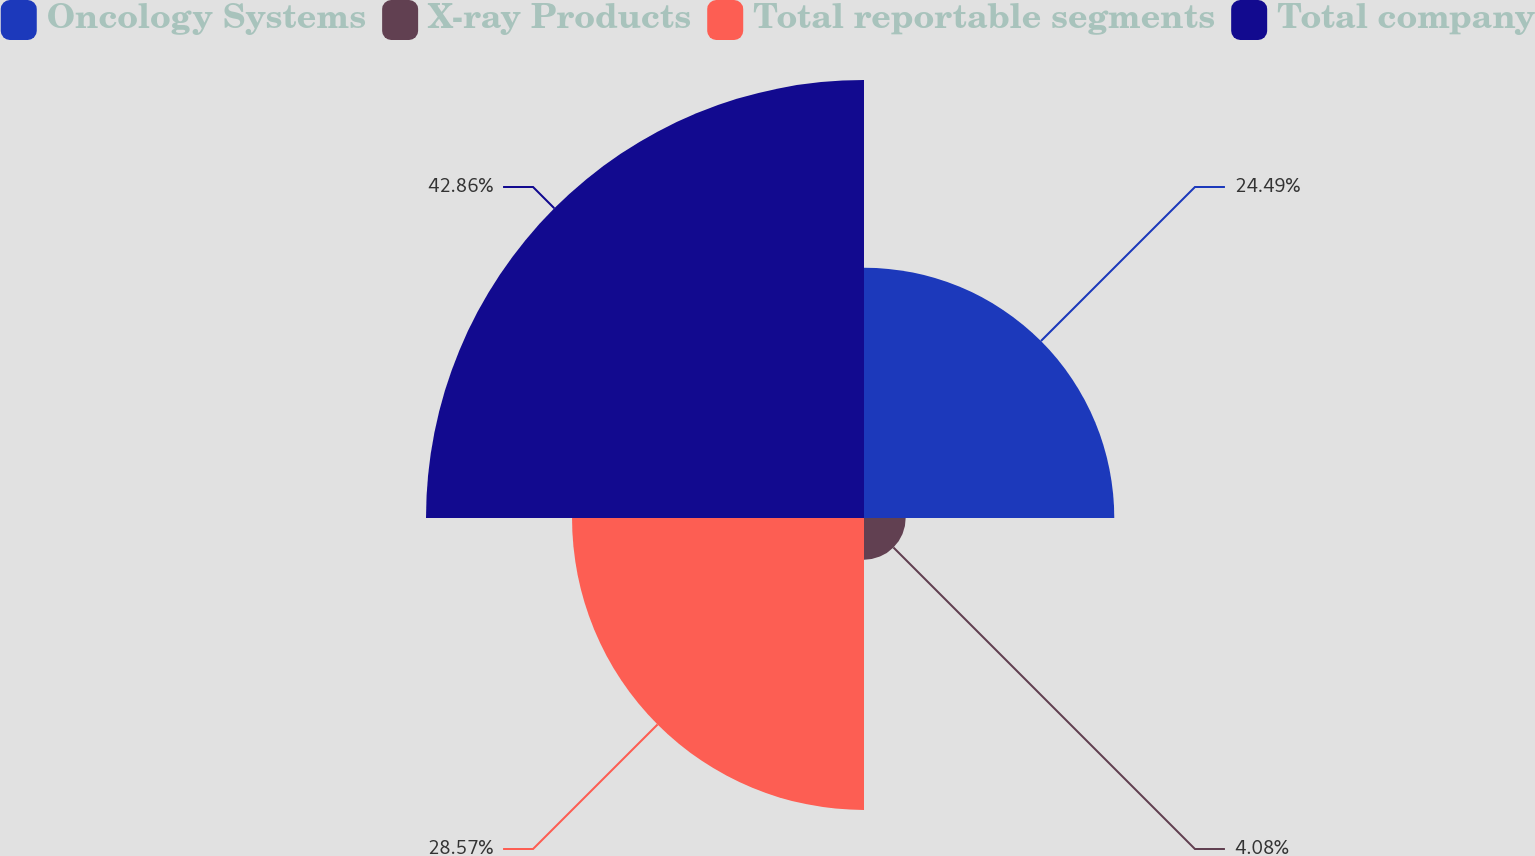Convert chart. <chart><loc_0><loc_0><loc_500><loc_500><pie_chart><fcel>Oncology Systems<fcel>X-ray Products<fcel>Total reportable segments<fcel>Total company<nl><fcel>24.49%<fcel>4.08%<fcel>28.57%<fcel>42.86%<nl></chart> 